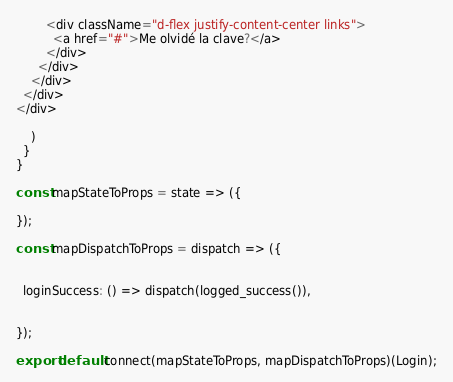<code> <loc_0><loc_0><loc_500><loc_500><_JavaScript_>        <div className="d-flex justify-content-center links">
          <a href="#">Me olvidé la clave?</a>
        </div>
      </div>
    </div>
  </div>
</div>

    )
  }
}

const mapStateToProps = state => ({

});

const mapDispatchToProps = dispatch => ({

 
  loginSuccess: () => dispatch(logged_success()),


});

export default connect(mapStateToProps, mapDispatchToProps)(Login);
</code> 